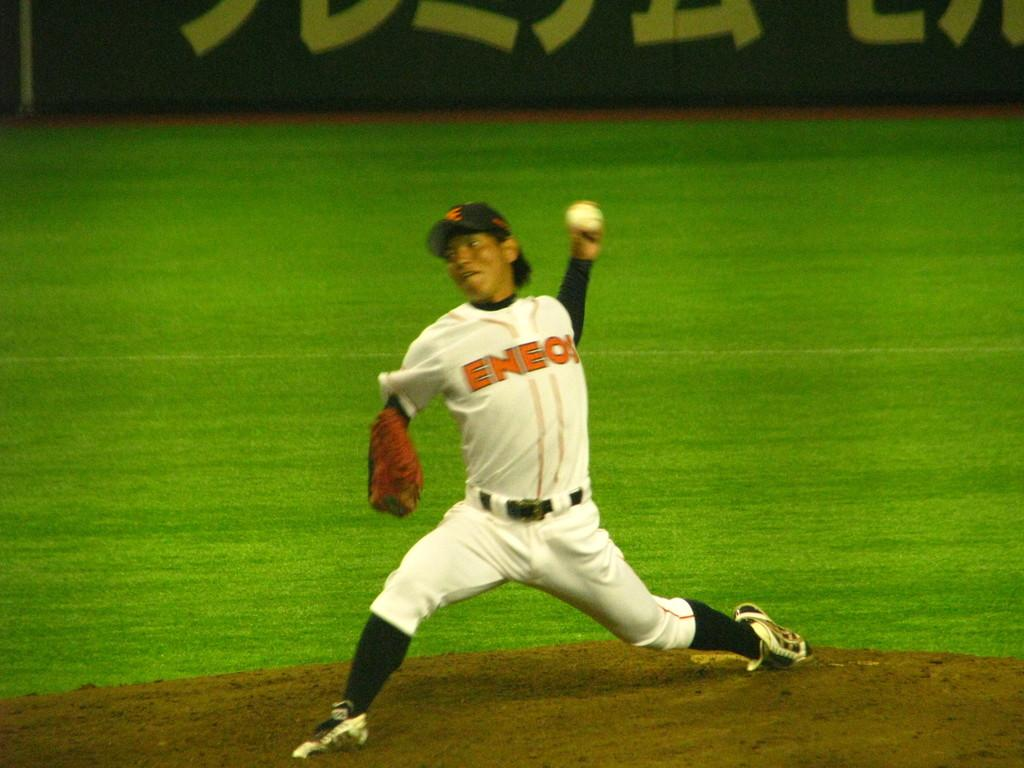<image>
Give a short and clear explanation of the subsequent image. A baseball pitcher wears a uniform bearing the company name ENEOS. 